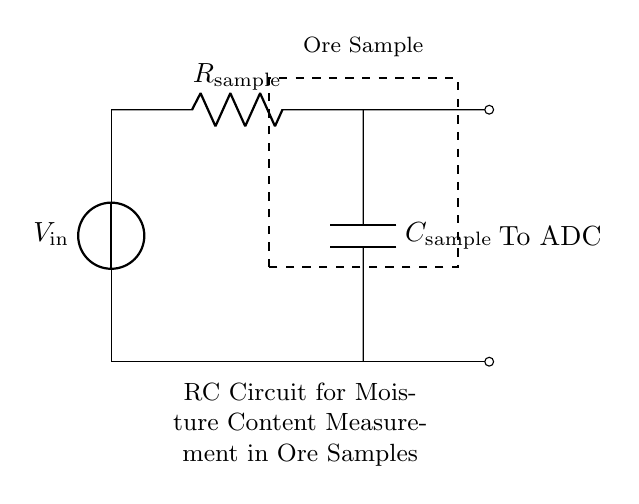What type of circuit is depicted in the diagram? The circuit is an RC circuit characterized by the presence of a resistor and a capacitor.
Answer: RC circuit What does the resistor in this circuit represent? The resistor labeled R_sample represents the resistance of the ore sample being measured for moisture content.
Answer: Resistance of ore sample What is the purpose of the capacitor in this circuit? The capacitor labeled C_sample is there to store charge, which is vital for the measurement of the moisture content in the ore sample over time.
Answer: To store charge Where does the output signal go in this circuit? The output signal is directed to an Analog-to-Digital Converter (ADC) as indicated in the diagram.
Answer: To ADC How are the resistor and capacitor connected in this circuit? The resistor and capacitor are connected in series, indicating that the same current flows through them in the circuit.
Answer: In series What does the voltage source represent in this circuit? The voltage source, labeled V_in, provides the necessary electrical potential to drive current through the resistor and capacitor.
Answer: Provides voltage What is the function of the dashed rectangle in the circuit? The dashed rectangle indicates the section of the circuit where the ore sample is located, highlighting its significance in the measurement process.
Answer: Represents ore sample 